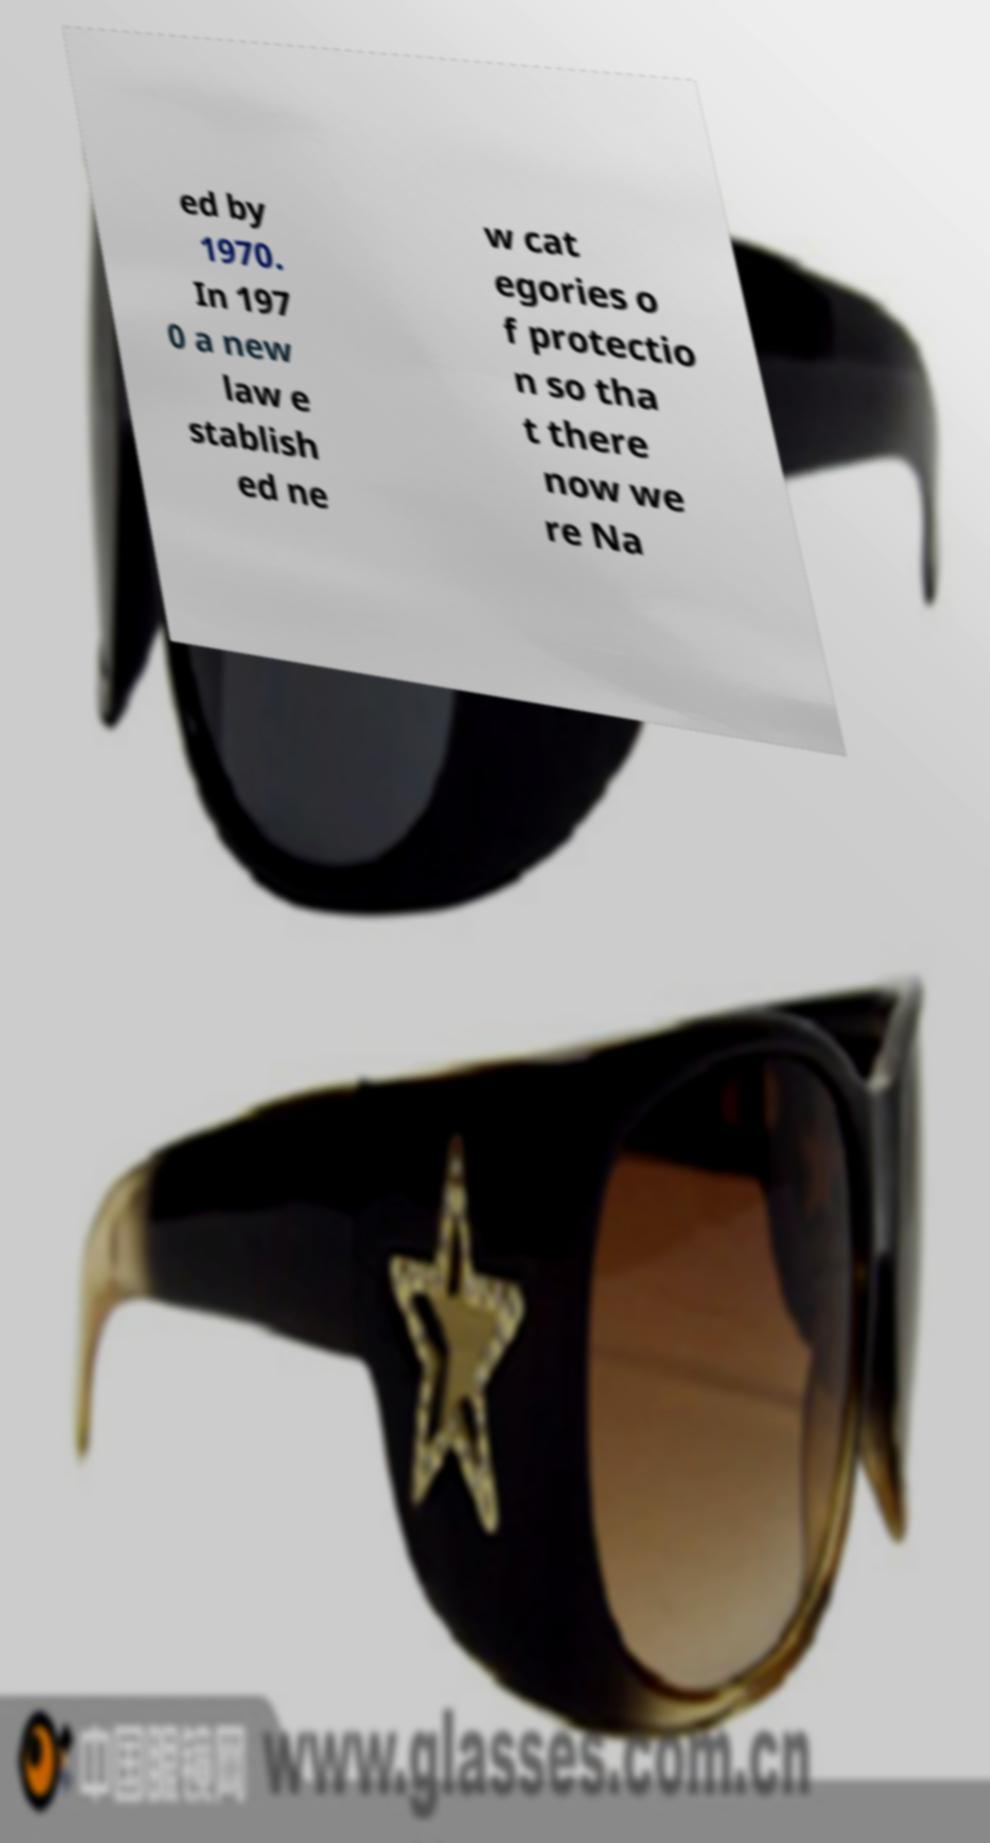Can you accurately transcribe the text from the provided image for me? ed by 1970. In 197 0 a new law e stablish ed ne w cat egories o f protectio n so tha t there now we re Na 